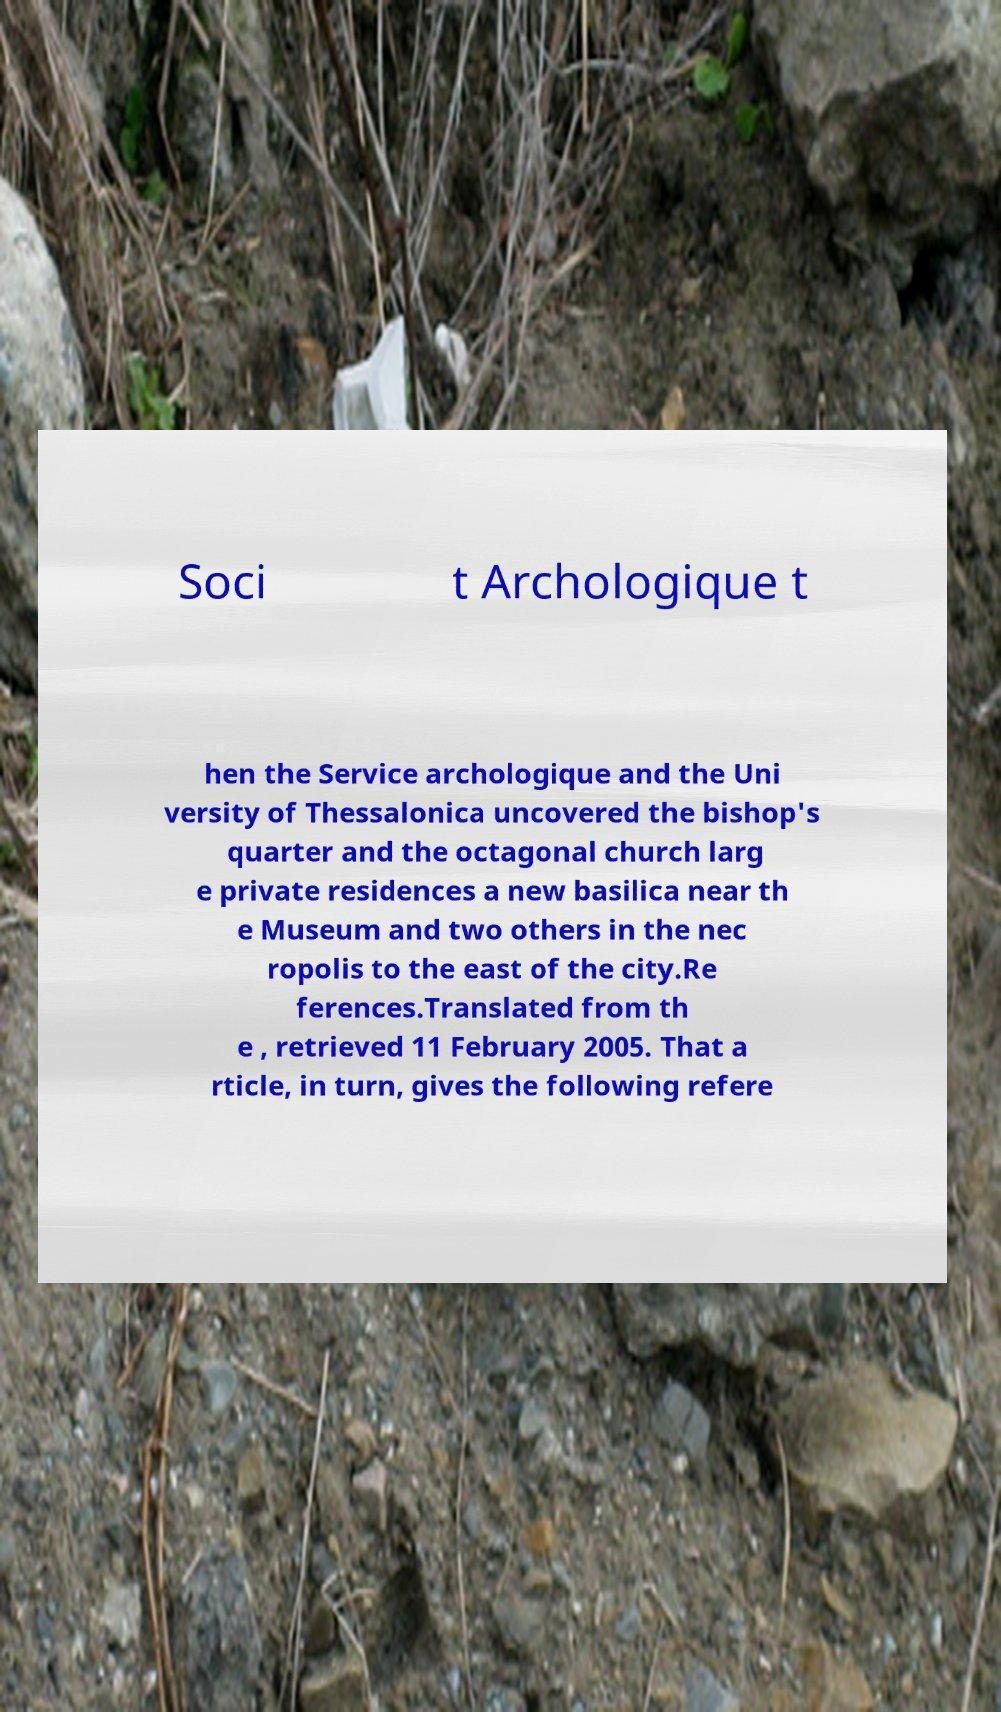Could you extract and type out the text from this image? Soci t Archologique t hen the Service archologique and the Uni versity of Thessalonica uncovered the bishop's quarter and the octagonal church larg e private residences a new basilica near th e Museum and two others in the nec ropolis to the east of the city.Re ferences.Translated from th e , retrieved 11 February 2005. That a rticle, in turn, gives the following refere 